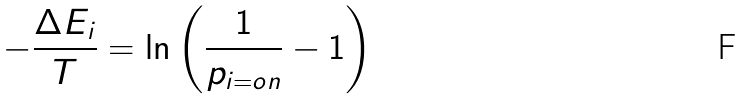Convert formula to latex. <formula><loc_0><loc_0><loc_500><loc_500>- { \frac { \Delta E _ { i } } { T } } = \ln \left ( { \frac { 1 } { p _ { i = o n } } } - 1 \right )</formula> 